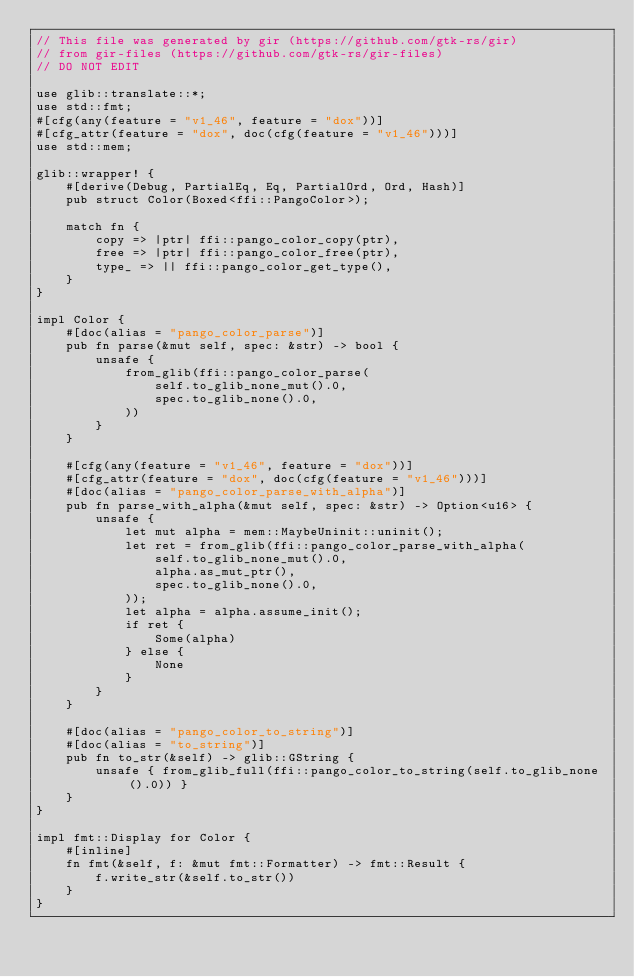Convert code to text. <code><loc_0><loc_0><loc_500><loc_500><_Rust_>// This file was generated by gir (https://github.com/gtk-rs/gir)
// from gir-files (https://github.com/gtk-rs/gir-files)
// DO NOT EDIT

use glib::translate::*;
use std::fmt;
#[cfg(any(feature = "v1_46", feature = "dox"))]
#[cfg_attr(feature = "dox", doc(cfg(feature = "v1_46")))]
use std::mem;

glib::wrapper! {
    #[derive(Debug, PartialEq, Eq, PartialOrd, Ord, Hash)]
    pub struct Color(Boxed<ffi::PangoColor>);

    match fn {
        copy => |ptr| ffi::pango_color_copy(ptr),
        free => |ptr| ffi::pango_color_free(ptr),
        type_ => || ffi::pango_color_get_type(),
    }
}

impl Color {
    #[doc(alias = "pango_color_parse")]
    pub fn parse(&mut self, spec: &str) -> bool {
        unsafe {
            from_glib(ffi::pango_color_parse(
                self.to_glib_none_mut().0,
                spec.to_glib_none().0,
            ))
        }
    }

    #[cfg(any(feature = "v1_46", feature = "dox"))]
    #[cfg_attr(feature = "dox", doc(cfg(feature = "v1_46")))]
    #[doc(alias = "pango_color_parse_with_alpha")]
    pub fn parse_with_alpha(&mut self, spec: &str) -> Option<u16> {
        unsafe {
            let mut alpha = mem::MaybeUninit::uninit();
            let ret = from_glib(ffi::pango_color_parse_with_alpha(
                self.to_glib_none_mut().0,
                alpha.as_mut_ptr(),
                spec.to_glib_none().0,
            ));
            let alpha = alpha.assume_init();
            if ret {
                Some(alpha)
            } else {
                None
            }
        }
    }

    #[doc(alias = "pango_color_to_string")]
    #[doc(alias = "to_string")]
    pub fn to_str(&self) -> glib::GString {
        unsafe { from_glib_full(ffi::pango_color_to_string(self.to_glib_none().0)) }
    }
}

impl fmt::Display for Color {
    #[inline]
    fn fmt(&self, f: &mut fmt::Formatter) -> fmt::Result {
        f.write_str(&self.to_str())
    }
}
</code> 